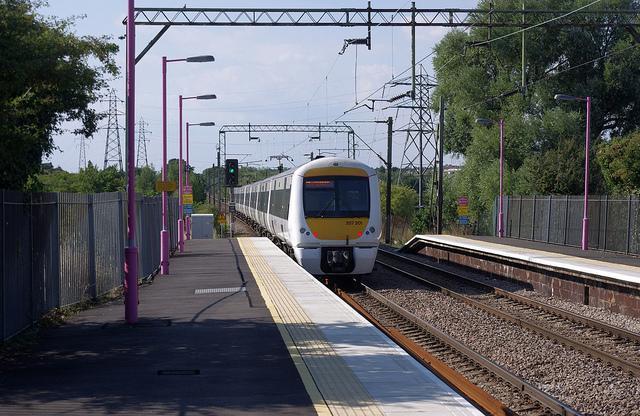How many tracks are there?
Give a very brief answer. 2. How many people are in front of the tables?
Give a very brief answer. 0. 